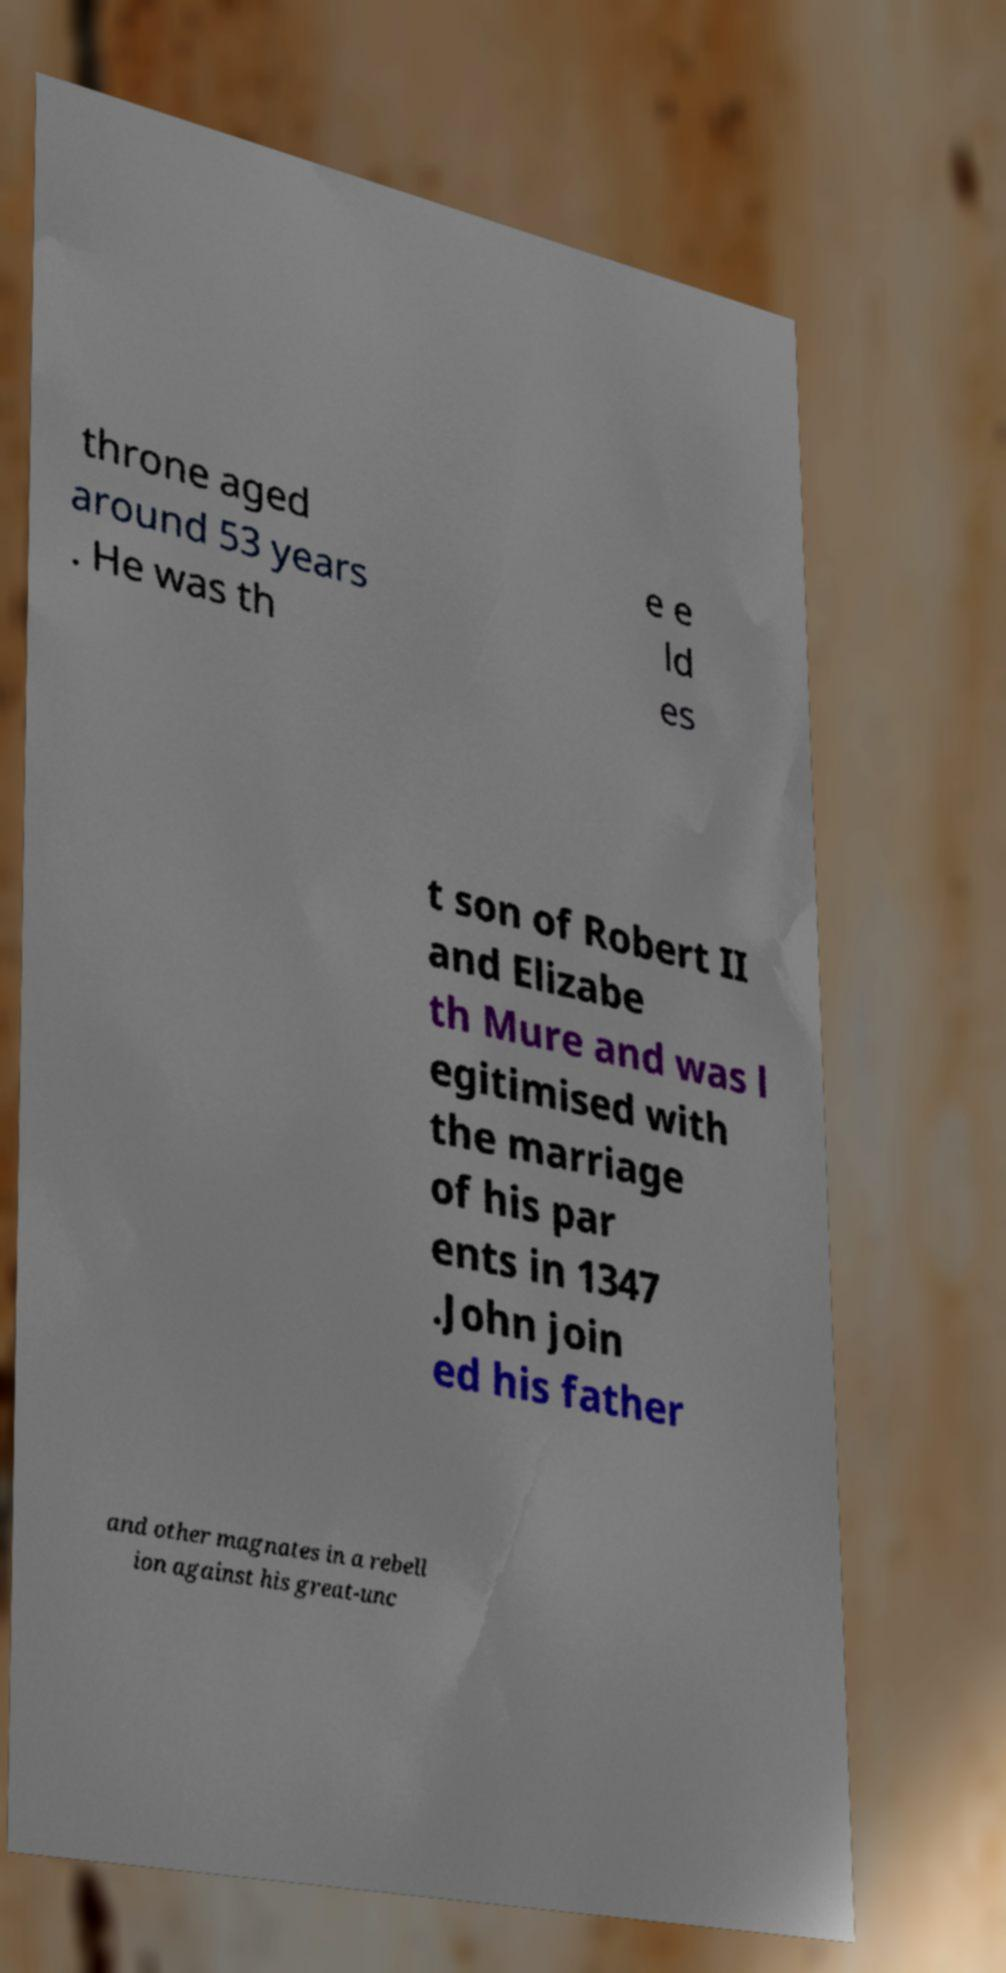Could you assist in decoding the text presented in this image and type it out clearly? throne aged around 53 years . He was th e e ld es t son of Robert II and Elizabe th Mure and was l egitimised with the marriage of his par ents in 1347 .John join ed his father and other magnates in a rebell ion against his great-unc 